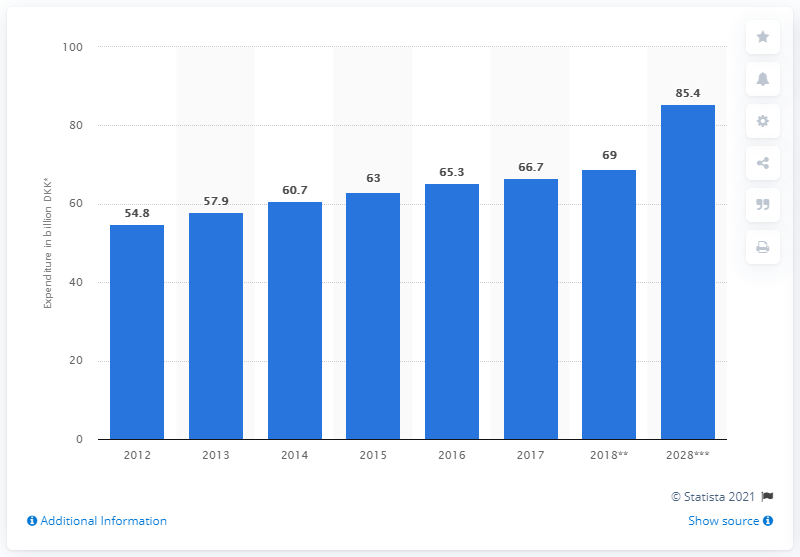Identify some key points in this picture. In 2017, the expenditure of domestic tourists in Denmark was approximately 66.7 billion Danish kroner. In 2018, the total amount of money spent by residents of Denmark on domestic tourism was approximately 69 billion Danish kroner. 